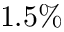Convert formula to latex. <formula><loc_0><loc_0><loc_500><loc_500>1 . 5 \%</formula> 